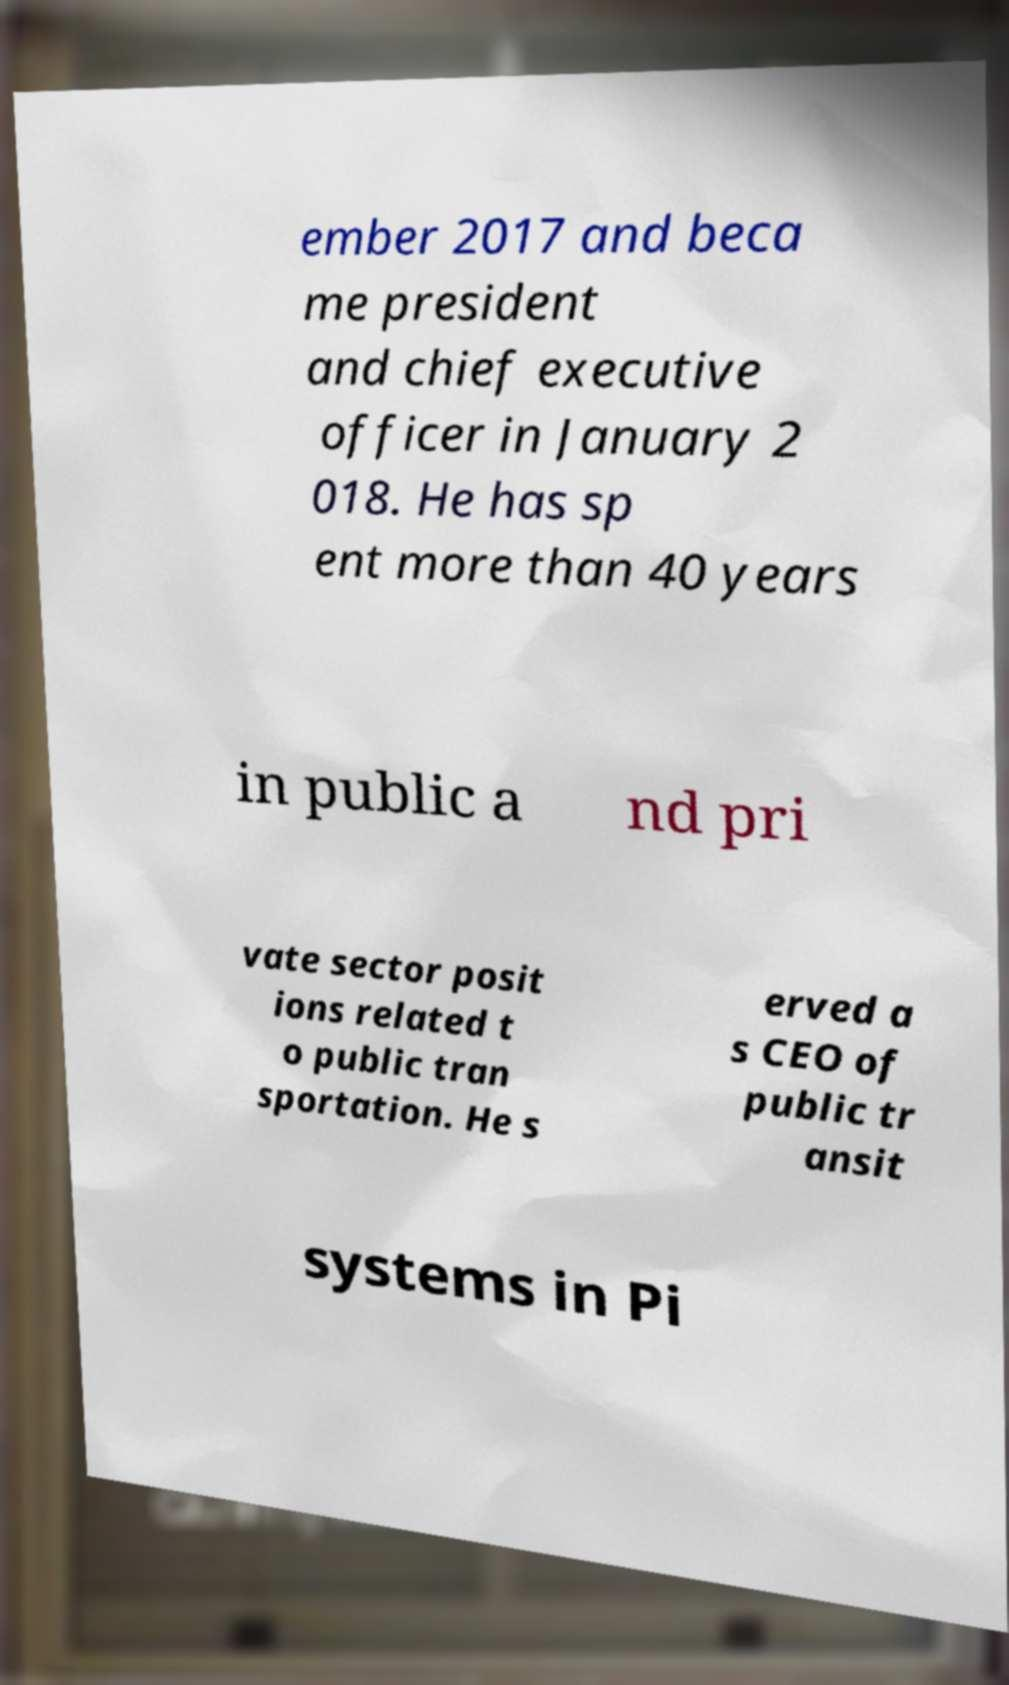Can you accurately transcribe the text from the provided image for me? ember 2017 and beca me president and chief executive officer in January 2 018. He has sp ent more than 40 years in public a nd pri vate sector posit ions related t o public tran sportation. He s erved a s CEO of public tr ansit systems in Pi 